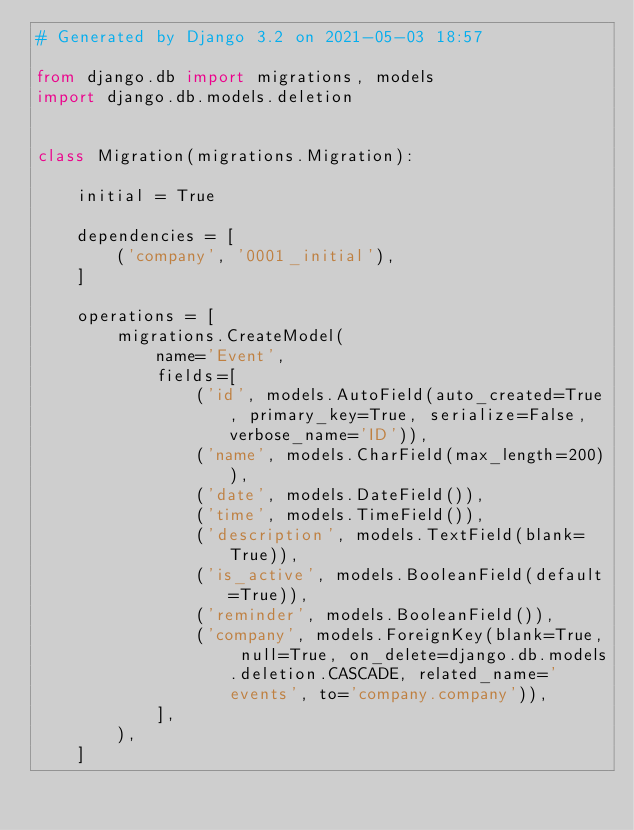<code> <loc_0><loc_0><loc_500><loc_500><_Python_># Generated by Django 3.2 on 2021-05-03 18:57

from django.db import migrations, models
import django.db.models.deletion


class Migration(migrations.Migration):

    initial = True

    dependencies = [
        ('company', '0001_initial'),
    ]

    operations = [
        migrations.CreateModel(
            name='Event',
            fields=[
                ('id', models.AutoField(auto_created=True, primary_key=True, serialize=False, verbose_name='ID')),
                ('name', models.CharField(max_length=200)),
                ('date', models.DateField()),
                ('time', models.TimeField()),
                ('description', models.TextField(blank=True)),
                ('is_active', models.BooleanField(default=True)),
                ('reminder', models.BooleanField()),
                ('company', models.ForeignKey(blank=True, null=True, on_delete=django.db.models.deletion.CASCADE, related_name='events', to='company.company')),
            ],
        ),
    ]
</code> 